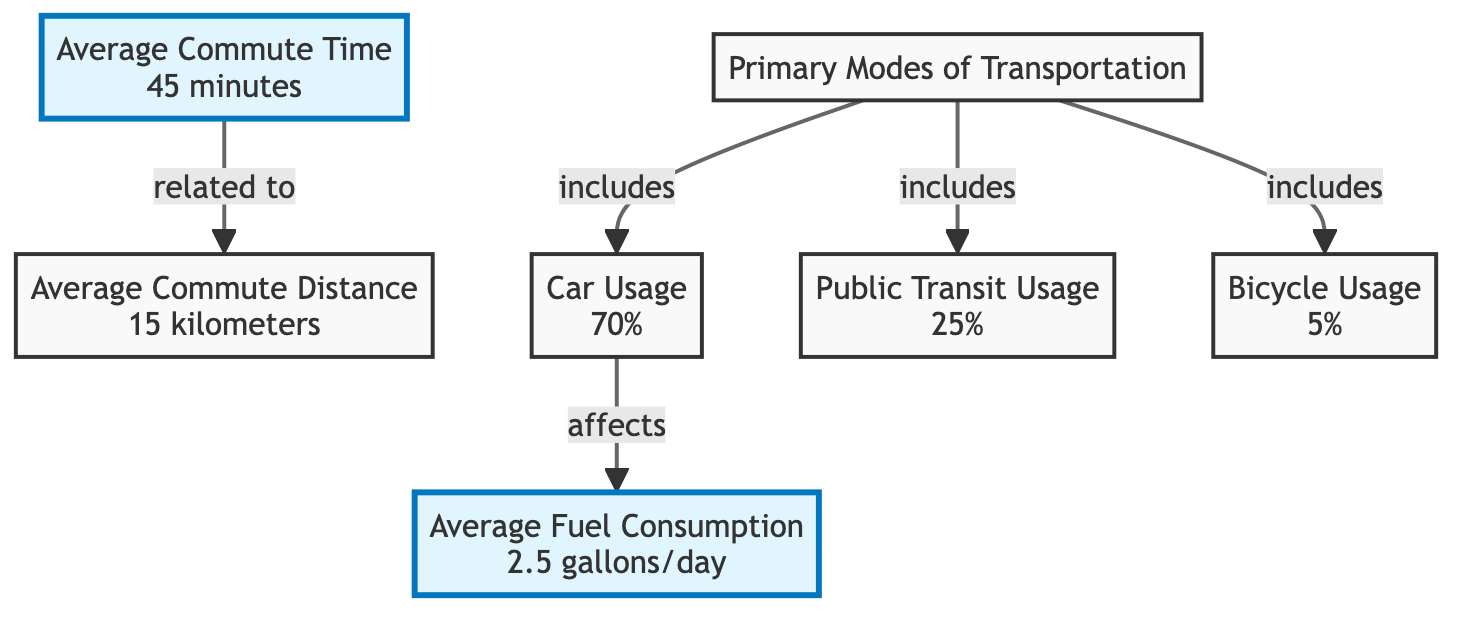What is the average commute time for Toronto mechanics? The diagram explicitly states that the average commute time is 45 minutes. This information is directly presented in node A, making it easy to identify.
Answer: 45 minutes What percentage of Toronto mechanics use cars for commuting? According to the diagram, car usage accounts for 70% of the primary modes of transportation mentioned, which is illustrated in node D connected to node B.
Answer: 70% How far is the average commute distance for Toronto mechanics? The average commute distance is indicated in node G of the diagram, which shows a value of 15 kilometers. This information provides a direct response to the question of distance.
Answer: 15 kilometers What is the average fuel consumption per day for Toronto mechanics? The diagram specifies that the average fuel consumption is 2.5 gallons per day, which is found in node C. This figure is clearly stated and easily referenced in the diagram.
Answer: 2.5 gallons/day What percentage of Toronto mechanics uses public transit for commuting? The diagram indicates that public transit usage is 25%, which is illustrated in node E. This specific percentage allows for a clear and concise answer to the question.
Answer: 25% How is average fuel consumption related to car usage? The diagram shows a direct relationship where car usage (70%) affects average fuel consumption (2.5 gallons/day). This is indicated by the arrows connecting nodes D and C, highlighting the influence of transportation mode on fuel consumption.
Answer: Affects What are the primary modes of transportation used by Toronto mechanics? The diagram lists three primary modes of transportation: car usage, public transit usage, and bicycle usage. These are found in node B, with the respective percentages detailed in the connected nodes.
Answer: Car, Public Transit, Bicycle What is the total percentage of bicycle usage compared to other transportation modes? The diagram shows that bicycle usage accounts for 5% of the primary modes of transportation. By comparing this with car (70%) and public transit (25%), it becomes apparent that bicycle usage is significantly lower. Thus, the total for bicycles alone remains 5%.
Answer: 5% What are the relationships depicted between average commute time and distance? The diagram illustrates that average commute time (45 minutes) is related to average commute distance (15 kilometers) through a direct connection indicated by the arrow between nodes A and G. This relationship suggests a link between how long it takes to travel and the distance covered.
Answer: Related to 